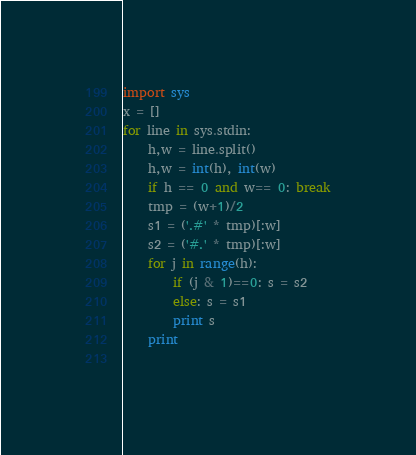Convert code to text. <code><loc_0><loc_0><loc_500><loc_500><_Python_>import sys
x = []
for line in sys.stdin:
    h,w = line.split()
    h,w = int(h), int(w)
    if h == 0 and w== 0: break
    tmp = (w+1)/2
    s1 = ('.#' * tmp)[:w]
    s2 = ('#.' * tmp)[:w]
    for j in range(h):
        if (j & 1)==0: s = s2
        else: s = s1
        print s
    print
    </code> 